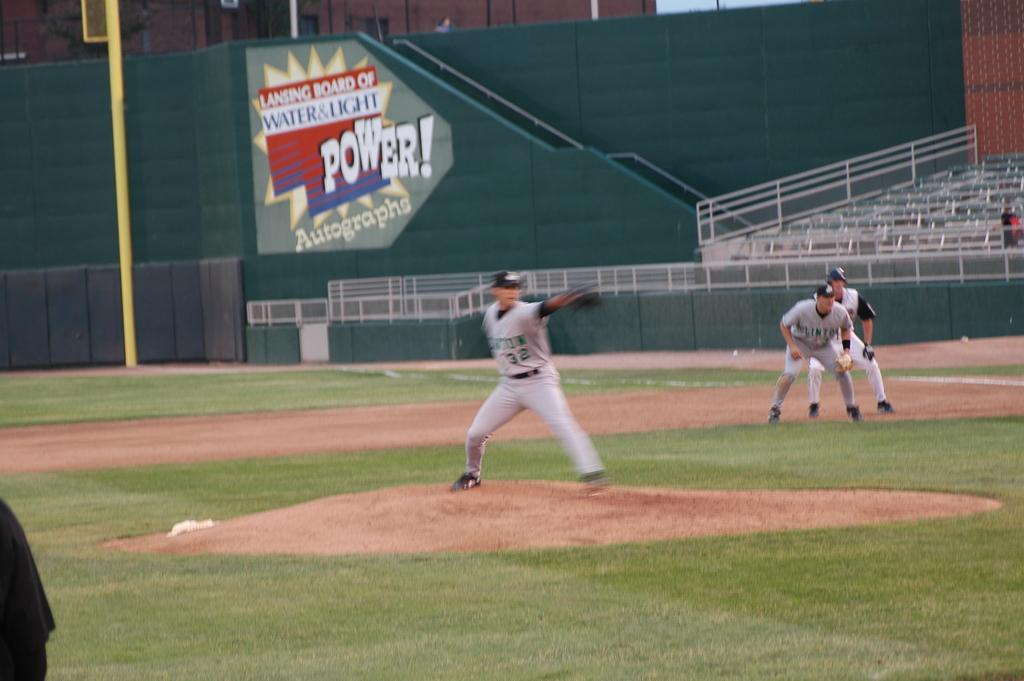<image>
Summarize the visual content of the image. a pitcher with the number 32 on his jersey 